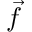Convert formula to latex. <formula><loc_0><loc_0><loc_500><loc_500>\vec { f }</formula> 